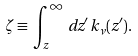<formula> <loc_0><loc_0><loc_500><loc_500>\zeta \equiv \, \int _ { z } ^ { \infty } \, d z ^ { \prime } \, k _ { \nu } ( z ^ { \prime } ) .</formula> 